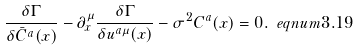<formula> <loc_0><loc_0><loc_500><loc_500>\frac { \delta \Gamma } { \delta \bar { C } ^ { a } ( x ) } - \partial _ { x } ^ { \mu } \frac { \delta \Gamma } { \delta u ^ { a \mu } ( x ) } - \sigma ^ { 2 } C ^ { a } ( x ) = 0 . \ e q n u m { 3 . 1 9 }</formula> 